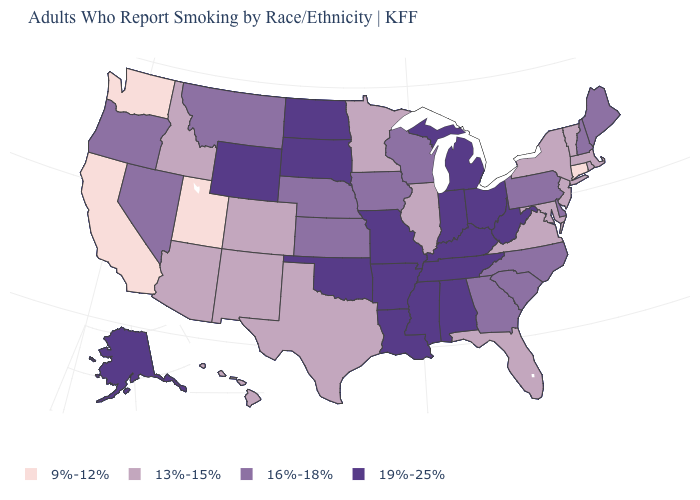Among the states that border Oklahoma , does Arkansas have the highest value?
Quick response, please. Yes. What is the value of Hawaii?
Concise answer only. 13%-15%. What is the value of Maine?
Quick response, please. 16%-18%. What is the value of California?
Answer briefly. 9%-12%. Name the states that have a value in the range 9%-12%?
Concise answer only. California, Connecticut, Utah, Washington. Name the states that have a value in the range 19%-25%?
Be succinct. Alabama, Alaska, Arkansas, Indiana, Kentucky, Louisiana, Michigan, Mississippi, Missouri, North Dakota, Ohio, Oklahoma, South Dakota, Tennessee, West Virginia, Wyoming. Does Oregon have a lower value than Rhode Island?
Quick response, please. No. Does Florida have a lower value than South Dakota?
Answer briefly. Yes. Does the first symbol in the legend represent the smallest category?
Quick response, please. Yes. Which states have the lowest value in the USA?
Quick response, please. California, Connecticut, Utah, Washington. Name the states that have a value in the range 9%-12%?
Be succinct. California, Connecticut, Utah, Washington. What is the value of North Carolina?
Write a very short answer. 16%-18%. How many symbols are there in the legend?
Be succinct. 4. Does Rhode Island have a lower value than California?
Answer briefly. No. Which states hav the highest value in the MidWest?
Quick response, please. Indiana, Michigan, Missouri, North Dakota, Ohio, South Dakota. 